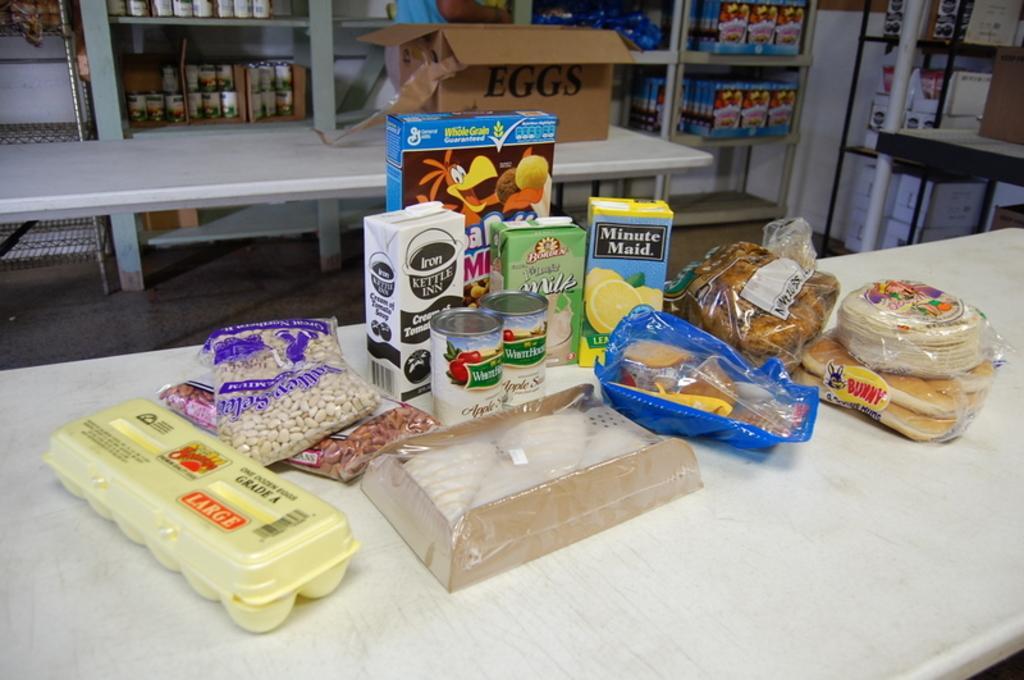How would you summarize this image in a sentence or two? Here we can see food items and a box on the tables. In the background we can see boxes and objects on the racks. 